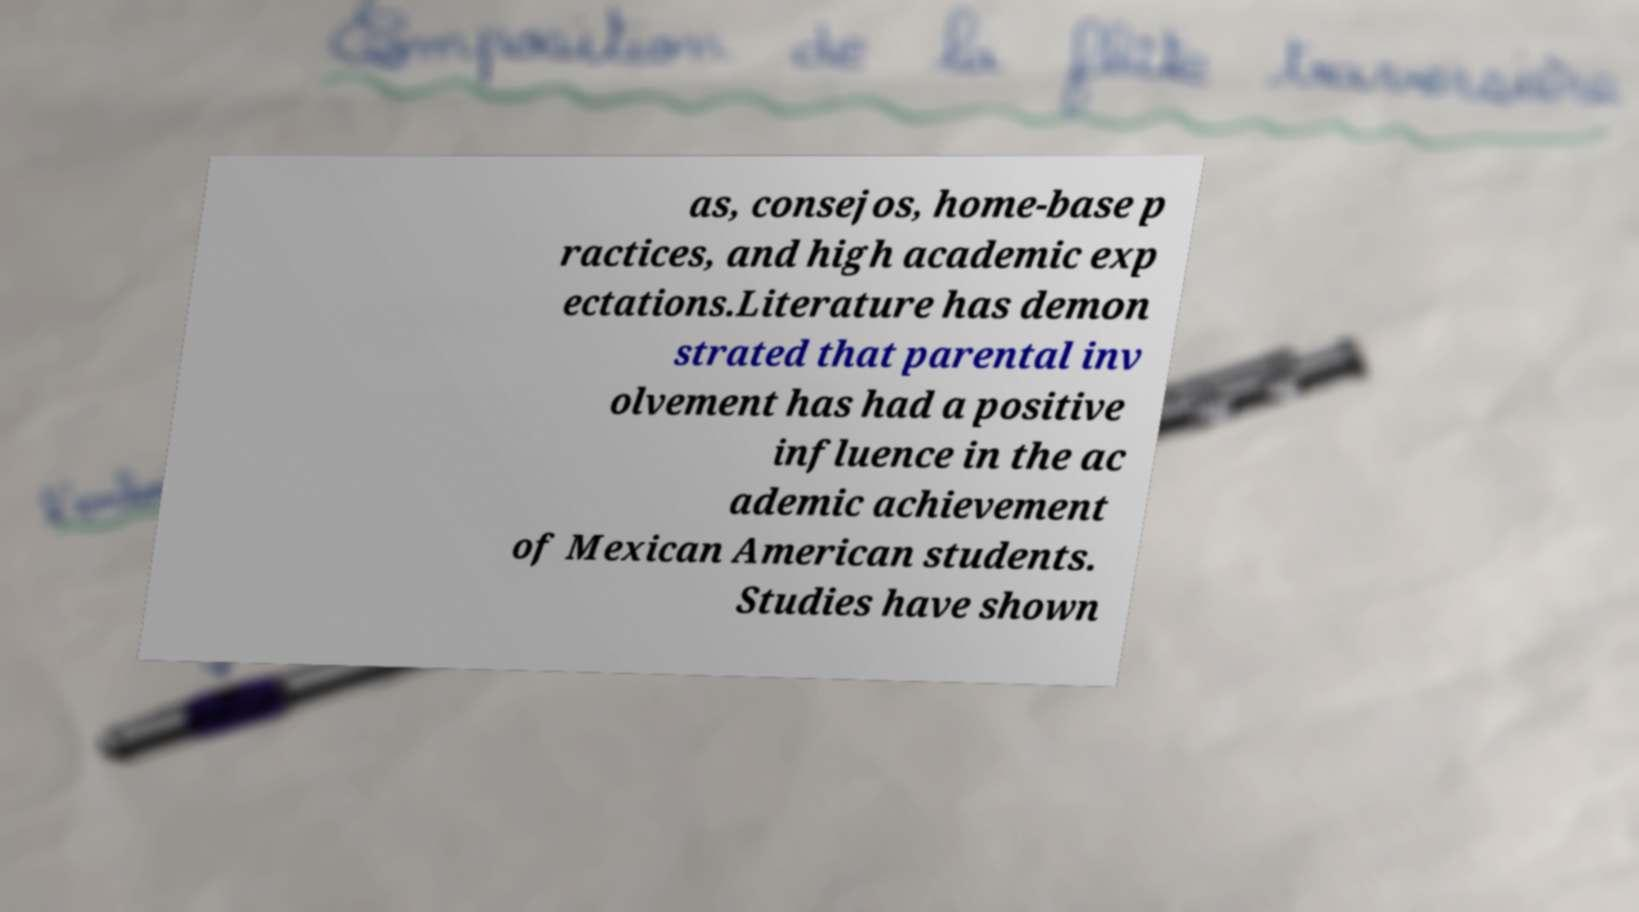Please read and relay the text visible in this image. What does it say? as, consejos, home-base p ractices, and high academic exp ectations.Literature has demon strated that parental inv olvement has had a positive influence in the ac ademic achievement of Mexican American students. Studies have shown 